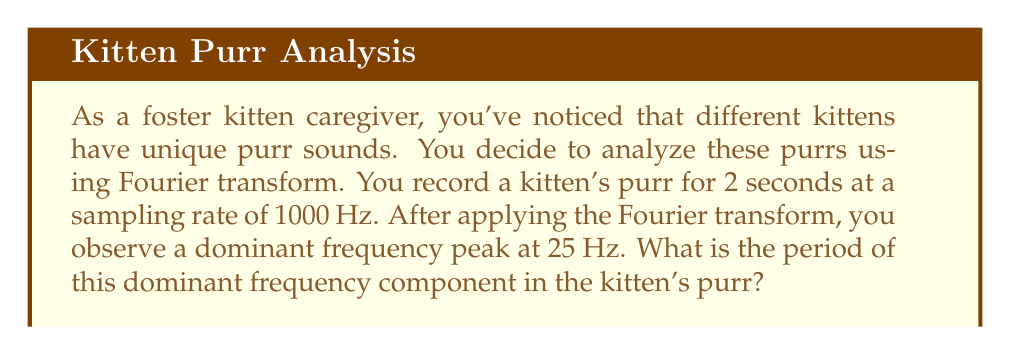Help me with this question. To solve this problem, we need to understand the relationship between frequency and period. The period is the reciprocal of the frequency.

1. The dominant frequency is given as 25 Hz.

2. The relationship between frequency ($f$) and period ($T$) is:

   $$T = \frac{1}{f}$$

3. Substituting the given frequency:

   $$T = \frac{1}{25 \text{ Hz}}$$

4. Simplify:
   
   $$T = 0.04 \text{ seconds}$$

5. To convert to milliseconds, multiply by 1000:

   $$T = 0.04 \times 1000 = 40 \text{ milliseconds}$$

Therefore, the period of the dominant frequency component in the kitten's purr is 40 milliseconds.
Answer: $40 \text{ milliseconds}$ 